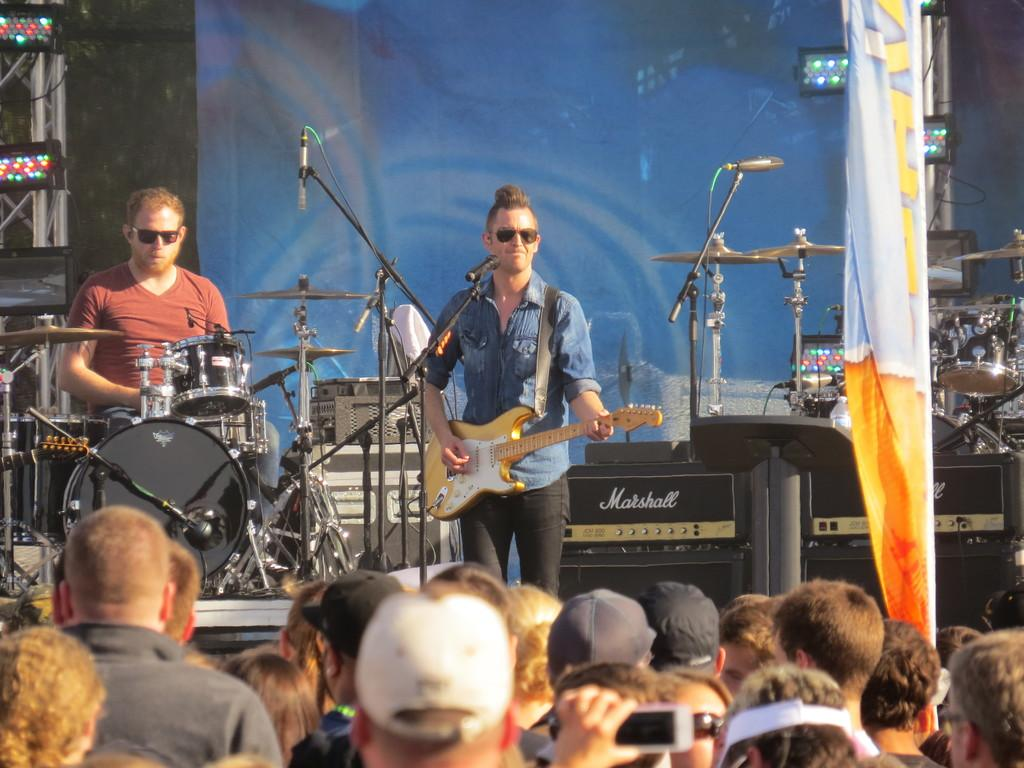How many musicians are playing in the image? There are two persons playing musical instruments in the image. What is in front of the musicians? There is a microphone in front of the musicians. Are there any spectators in the image? Yes, there are people watching the musicians. What type of lunchroom is visible in the image? There is no lunchroom present in the image. What educational institution are the musicians affiliated with in the image? There is no information about the musicians' affiliations or education in the image. 